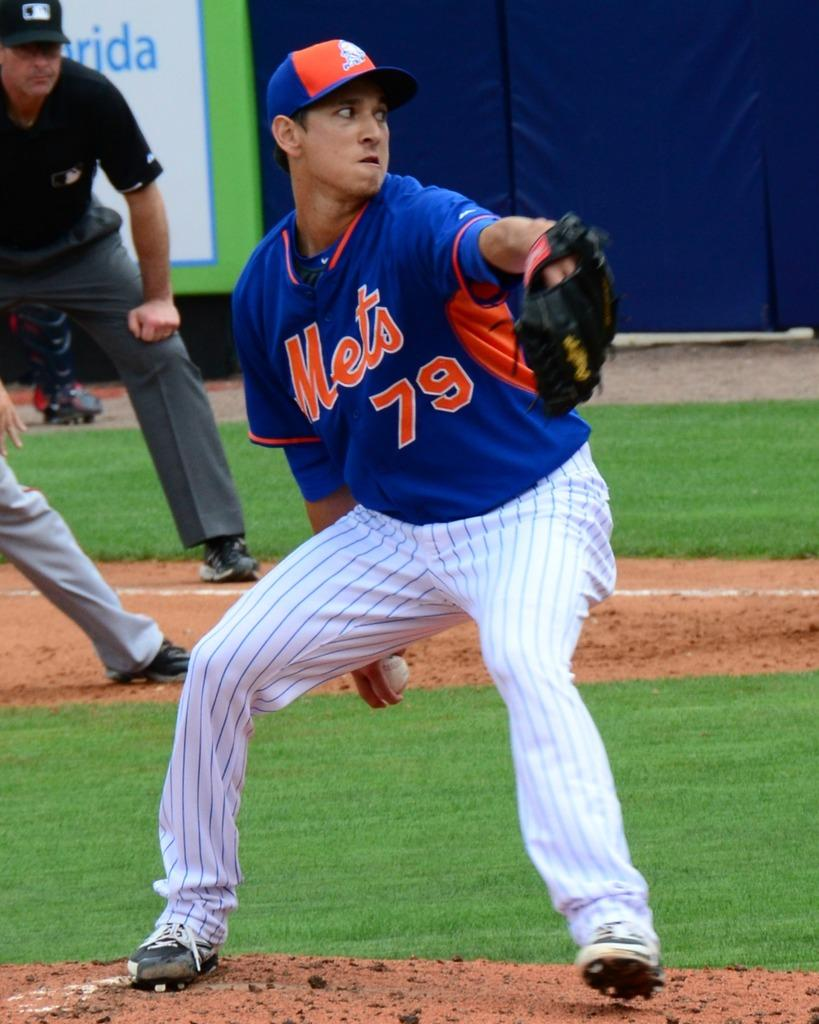Provide a one-sentence caption for the provided image. Mets pitcher number 79 is about to pitch the ball. 